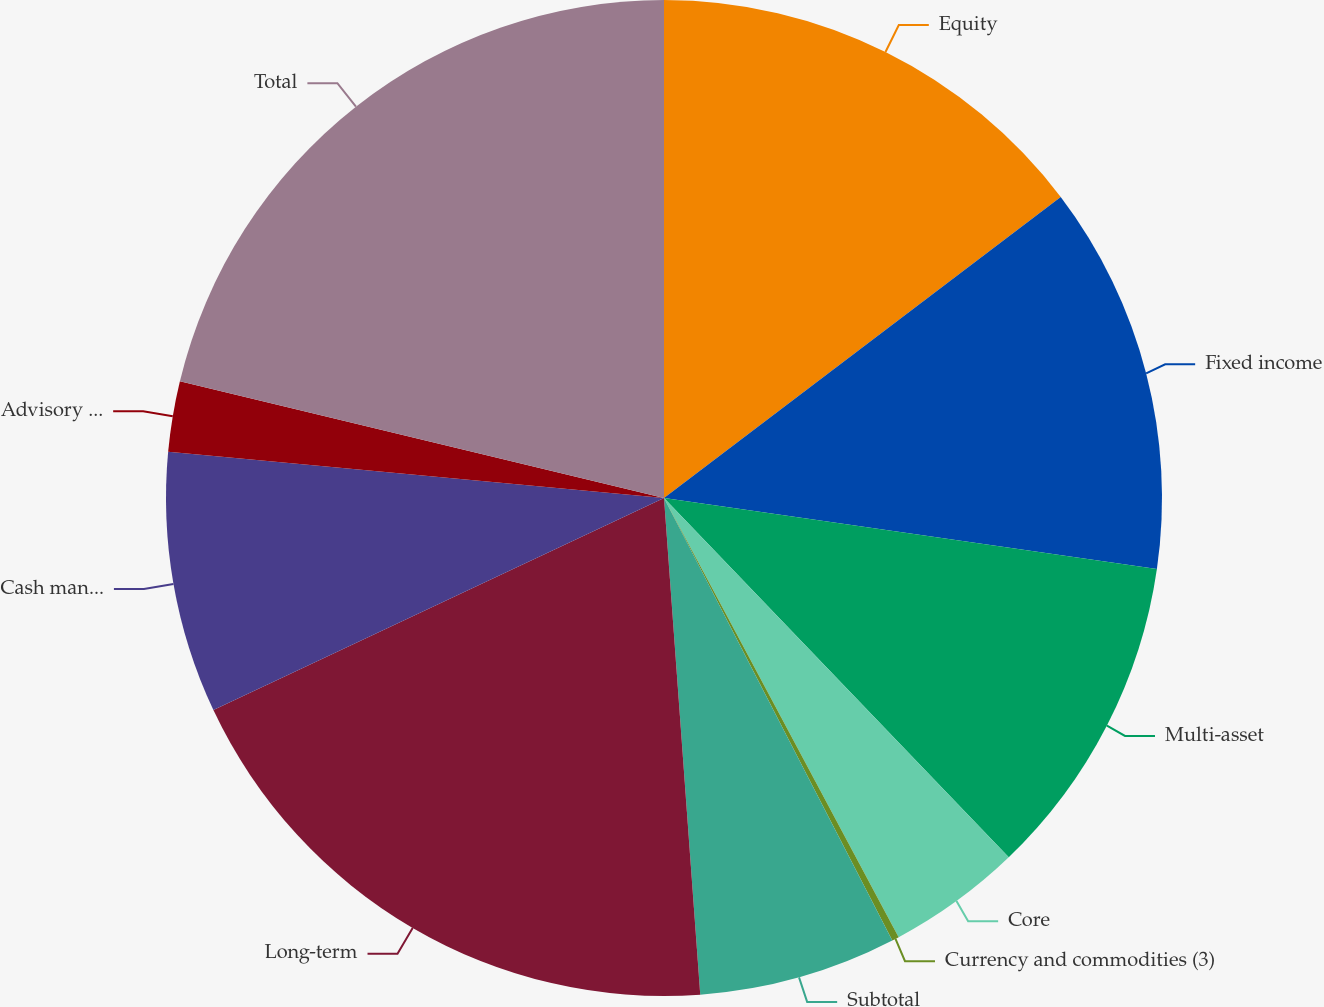Convert chart. <chart><loc_0><loc_0><loc_500><loc_500><pie_chart><fcel>Equity<fcel>Fixed income<fcel>Multi-asset<fcel>Core<fcel>Currency and commodities (3)<fcel>Subtotal<fcel>Long-term<fcel>Cash management<fcel>Advisory (2)<fcel>Total<nl><fcel>14.67%<fcel>12.61%<fcel>10.55%<fcel>4.36%<fcel>0.23%<fcel>6.42%<fcel>19.16%<fcel>8.48%<fcel>2.29%<fcel>21.23%<nl></chart> 